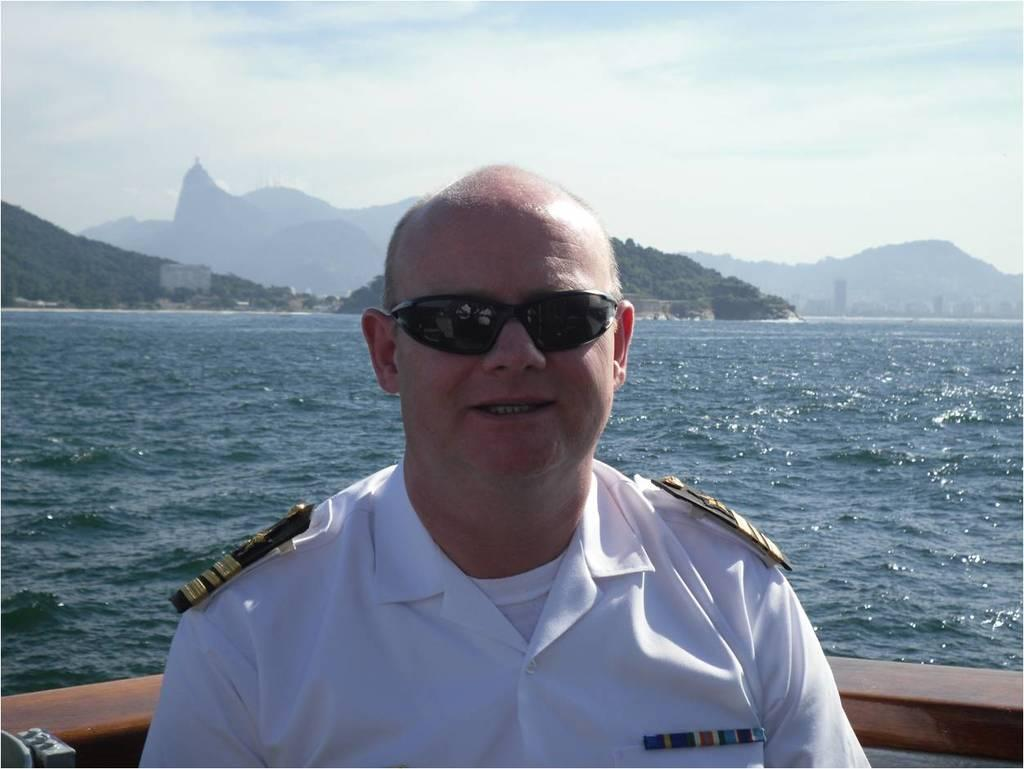What is the person in the image doing? There is a person sitting on a boat in the image. What can be seen in the distance behind the boat? There are mountains, trees, buildings, and water visible in the background of the image. What is visible at the top of the image? The sky is visible at the top of the image. What type of stick is the person using to tell jokes in the image? There is no stick or joke-telling activity present in the image. Can you see any blades in the image? There are no blades visible in the image. 